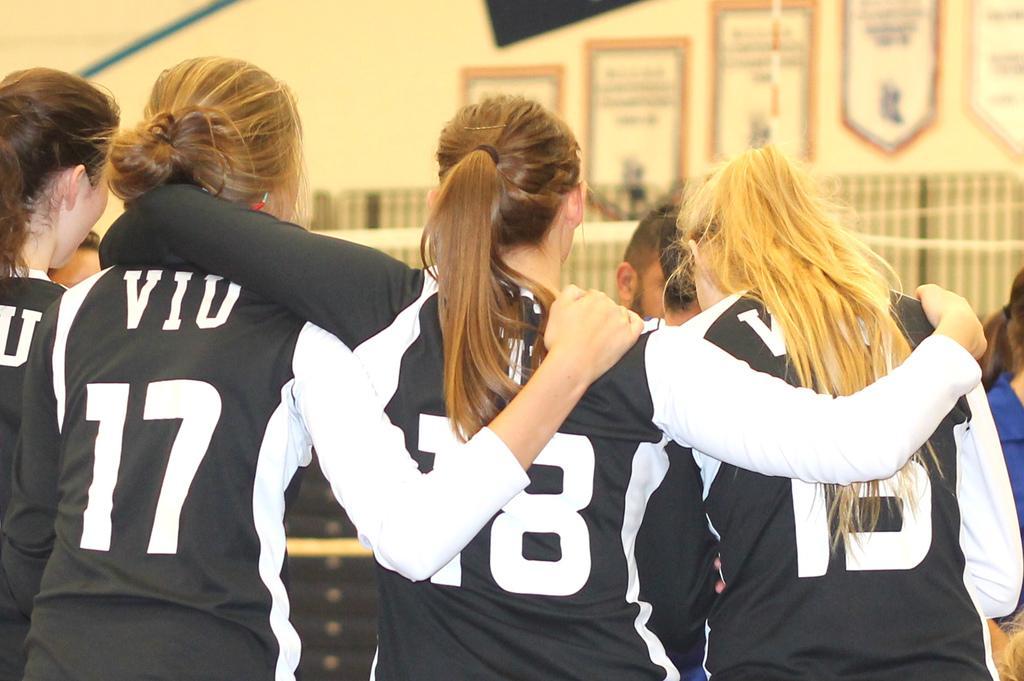Please provide a concise description of this image. In this image we can see four women are standing and they are wearing black and white color t-shirt. 